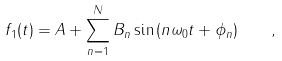Convert formula to latex. <formula><loc_0><loc_0><loc_500><loc_500>f _ { 1 } ( t ) = A + \sum _ { n = 1 } ^ { N } B _ { n } \sin { ( n \omega _ { 0 } t + \phi _ { n } ) } \quad ,</formula> 